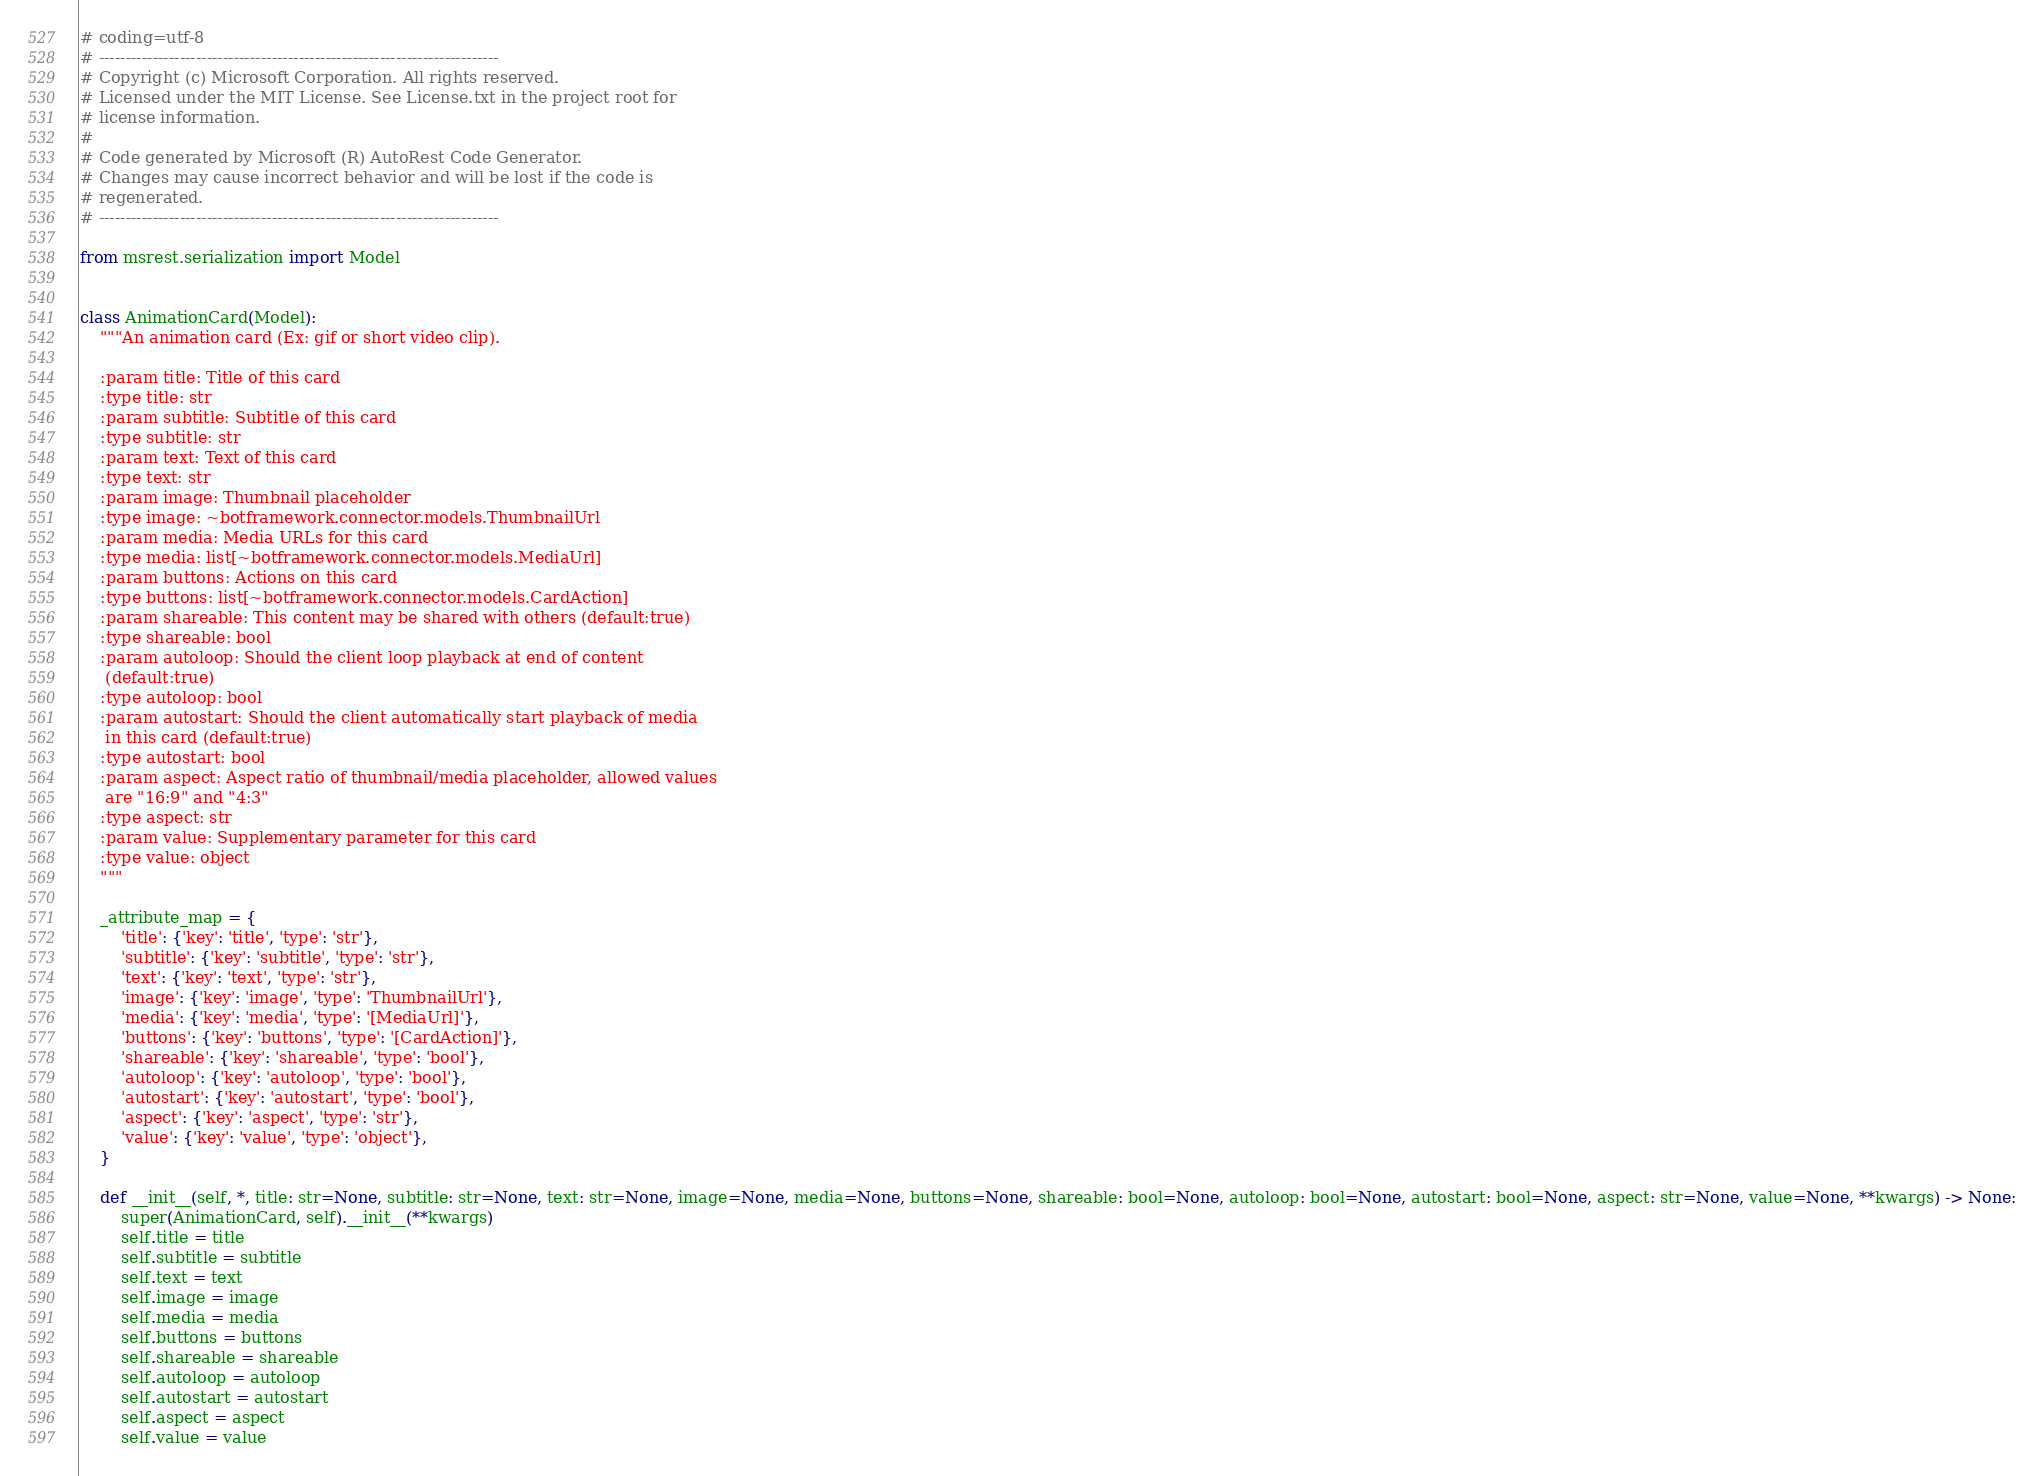<code> <loc_0><loc_0><loc_500><loc_500><_Python_># coding=utf-8
# --------------------------------------------------------------------------
# Copyright (c) Microsoft Corporation. All rights reserved.
# Licensed under the MIT License. See License.txt in the project root for
# license information.
#
# Code generated by Microsoft (R) AutoRest Code Generator.
# Changes may cause incorrect behavior and will be lost if the code is
# regenerated.
# --------------------------------------------------------------------------

from msrest.serialization import Model


class AnimationCard(Model):
    """An animation card (Ex: gif or short video clip).

    :param title: Title of this card
    :type title: str
    :param subtitle: Subtitle of this card
    :type subtitle: str
    :param text: Text of this card
    :type text: str
    :param image: Thumbnail placeholder
    :type image: ~botframework.connector.models.ThumbnailUrl
    :param media: Media URLs for this card
    :type media: list[~botframework.connector.models.MediaUrl]
    :param buttons: Actions on this card
    :type buttons: list[~botframework.connector.models.CardAction]
    :param shareable: This content may be shared with others (default:true)
    :type shareable: bool
    :param autoloop: Should the client loop playback at end of content
     (default:true)
    :type autoloop: bool
    :param autostart: Should the client automatically start playback of media
     in this card (default:true)
    :type autostart: bool
    :param aspect: Aspect ratio of thumbnail/media placeholder, allowed values
     are "16:9" and "4:3"
    :type aspect: str
    :param value: Supplementary parameter for this card
    :type value: object
    """

    _attribute_map = {
        'title': {'key': 'title', 'type': 'str'},
        'subtitle': {'key': 'subtitle', 'type': 'str'},
        'text': {'key': 'text', 'type': 'str'},
        'image': {'key': 'image', 'type': 'ThumbnailUrl'},
        'media': {'key': 'media', 'type': '[MediaUrl]'},
        'buttons': {'key': 'buttons', 'type': '[CardAction]'},
        'shareable': {'key': 'shareable', 'type': 'bool'},
        'autoloop': {'key': 'autoloop', 'type': 'bool'},
        'autostart': {'key': 'autostart', 'type': 'bool'},
        'aspect': {'key': 'aspect', 'type': 'str'},
        'value': {'key': 'value', 'type': 'object'},
    }

    def __init__(self, *, title: str=None, subtitle: str=None, text: str=None, image=None, media=None, buttons=None, shareable: bool=None, autoloop: bool=None, autostart: bool=None, aspect: str=None, value=None, **kwargs) -> None:
        super(AnimationCard, self).__init__(**kwargs)
        self.title = title
        self.subtitle = subtitle
        self.text = text
        self.image = image
        self.media = media
        self.buttons = buttons
        self.shareable = shareable
        self.autoloop = autoloop
        self.autostart = autostart
        self.aspect = aspect
        self.value = value
</code> 